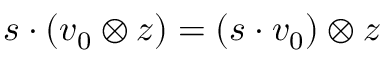Convert formula to latex. <formula><loc_0><loc_0><loc_500><loc_500>s \cdot ( v _ { 0 } \otimes z ) = ( s \cdot v _ { 0 } ) \otimes z</formula> 